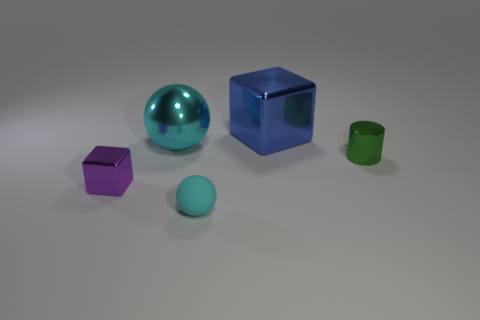Is there any other thing that has the same material as the tiny cyan sphere?
Offer a terse response. No. There is a big thing that is the same shape as the tiny cyan rubber thing; what material is it?
Ensure brevity in your answer.  Metal. What number of tiny brown shiny cylinders are there?
Ensure brevity in your answer.  0. There is a block that is behind the sphere that is behind the cyan object in front of the tiny green metal thing; what color is it?
Provide a succinct answer. Blue. Are there fewer large blue metal blocks than big brown shiny cubes?
Provide a succinct answer. No. There is another shiny thing that is the same shape as the large blue metal thing; what color is it?
Ensure brevity in your answer.  Purple. There is a cylinder that is the same material as the large cyan sphere; what color is it?
Make the answer very short. Green. How many yellow balls are the same size as the purple thing?
Keep it short and to the point. 0. What is the material of the large blue block?
Offer a very short reply. Metal. Are there more tiny green cylinders than cyan objects?
Your answer should be compact. No. 